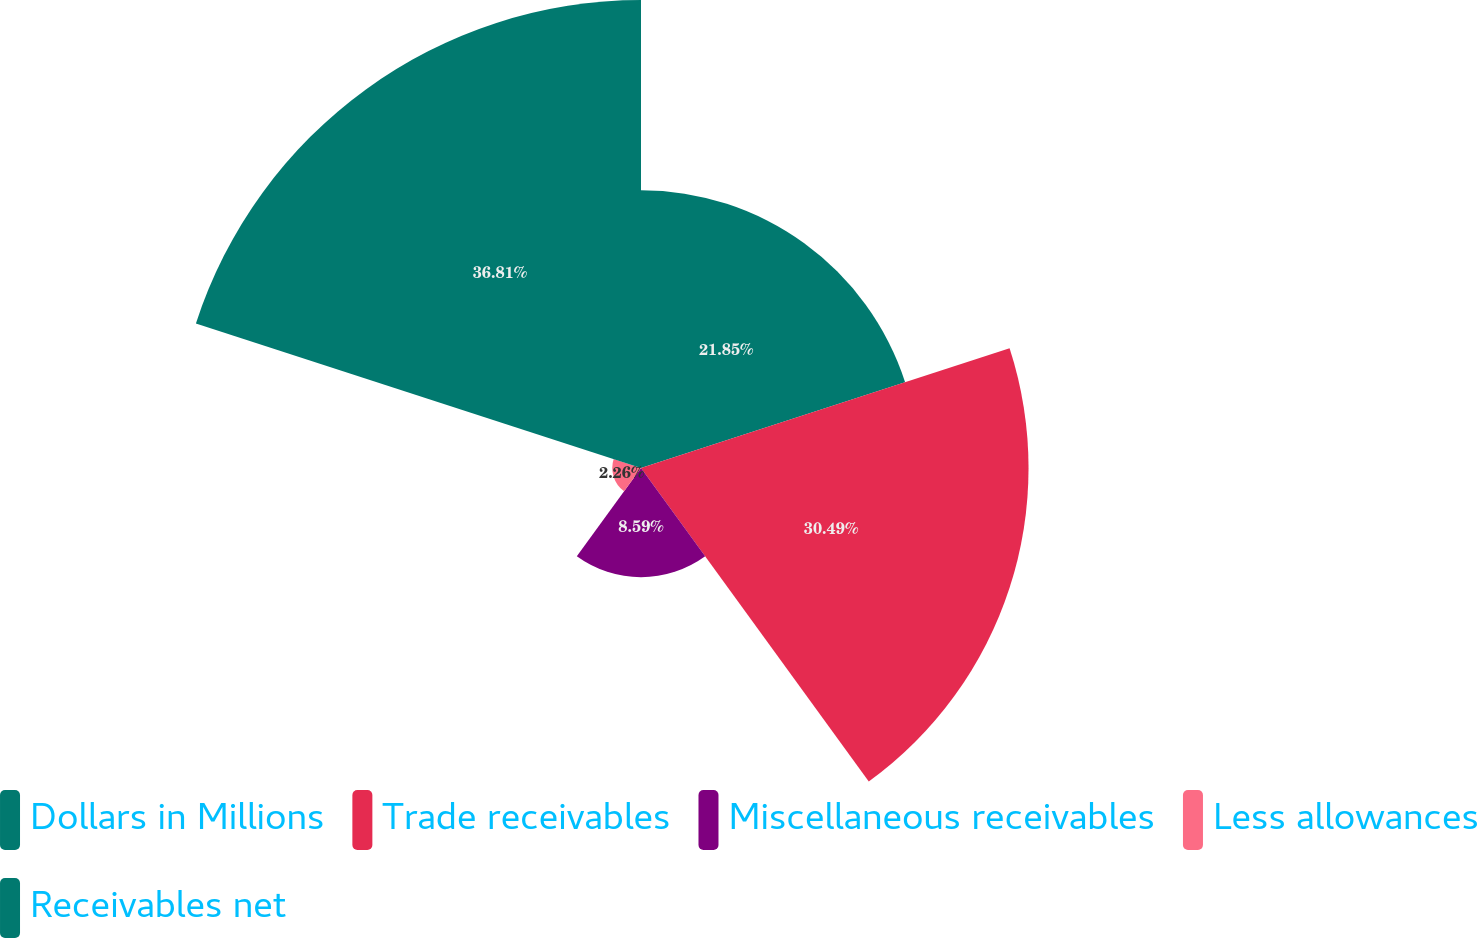<chart> <loc_0><loc_0><loc_500><loc_500><pie_chart><fcel>Dollars in Millions<fcel>Trade receivables<fcel>Miscellaneous receivables<fcel>Less allowances<fcel>Receivables net<nl><fcel>21.85%<fcel>30.49%<fcel>8.59%<fcel>2.26%<fcel>36.82%<nl></chart> 